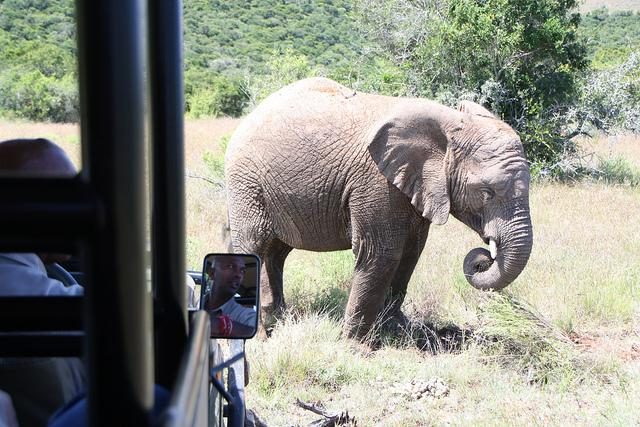What type of vehicle is the man on the left most likely riding in? Please explain your reasoning. jeep. One can see the bars of the vehicle and it doesn't appear to have a top over the riders which is common among these safari vehicles. 